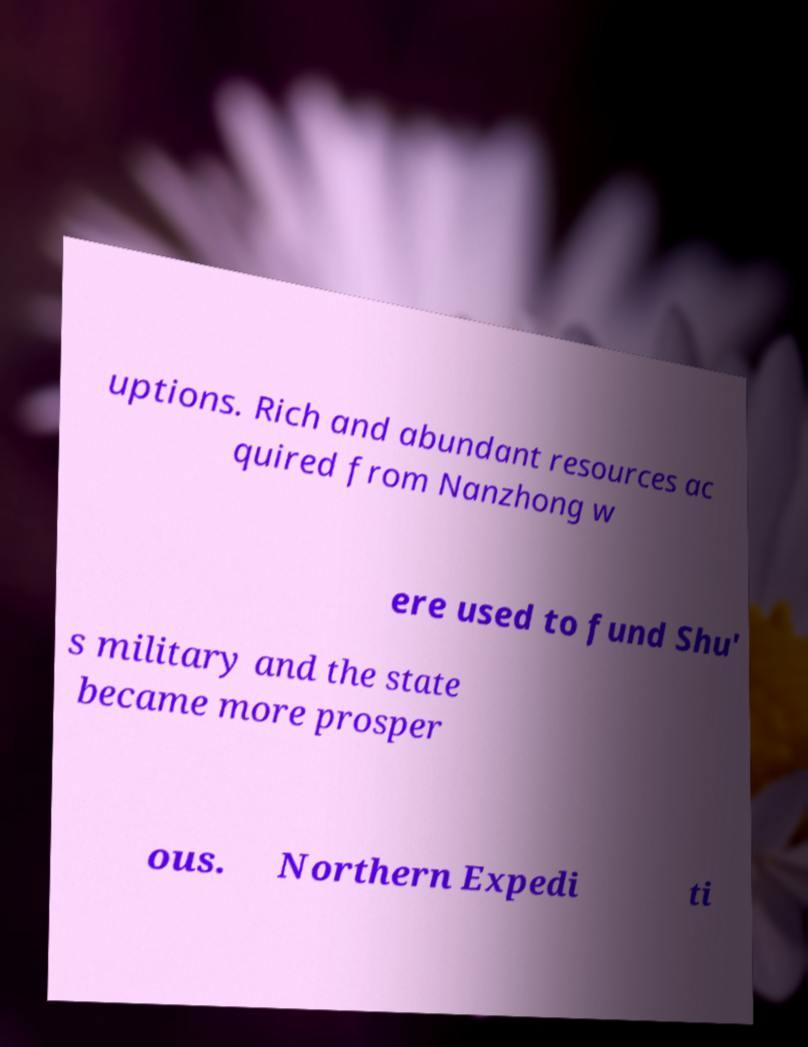For documentation purposes, I need the text within this image transcribed. Could you provide that? uptions. Rich and abundant resources ac quired from Nanzhong w ere used to fund Shu' s military and the state became more prosper ous. Northern Expedi ti 